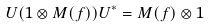Convert formula to latex. <formula><loc_0><loc_0><loc_500><loc_500>U ( 1 \otimes M ( f ) ) U ^ { * } = M ( f ) \otimes 1</formula> 